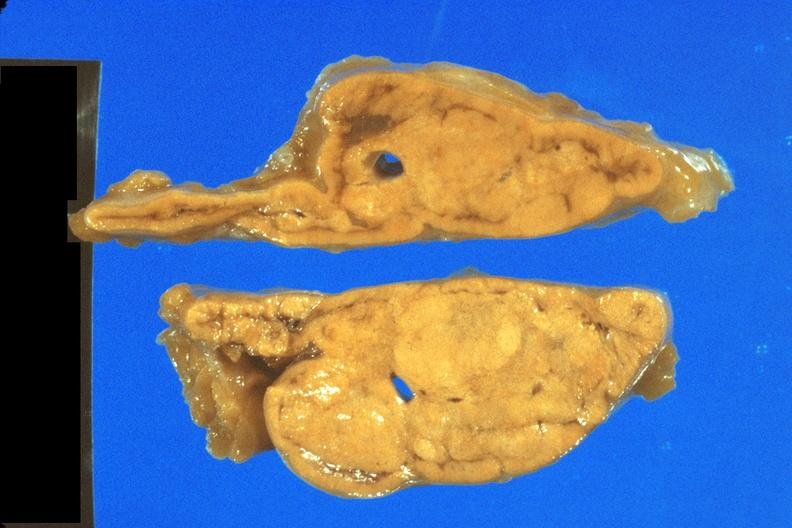what is present?
Answer the question using a single word or phrase. Adrenal 